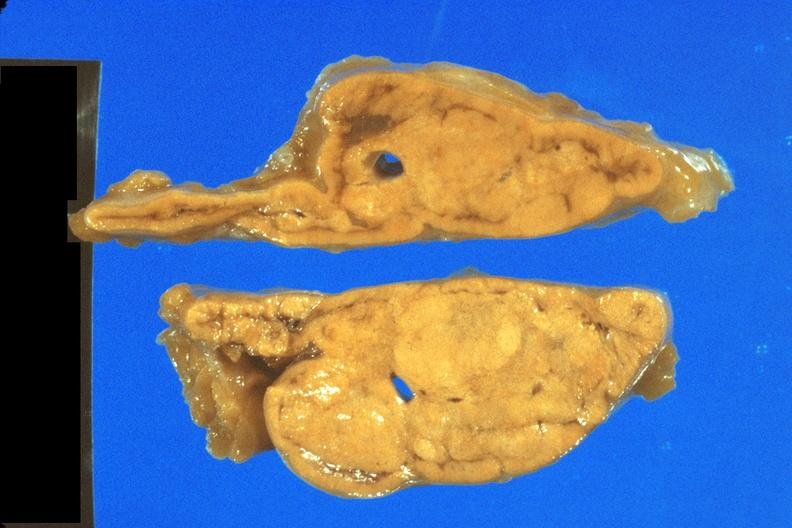what is present?
Answer the question using a single word or phrase. Adrenal 